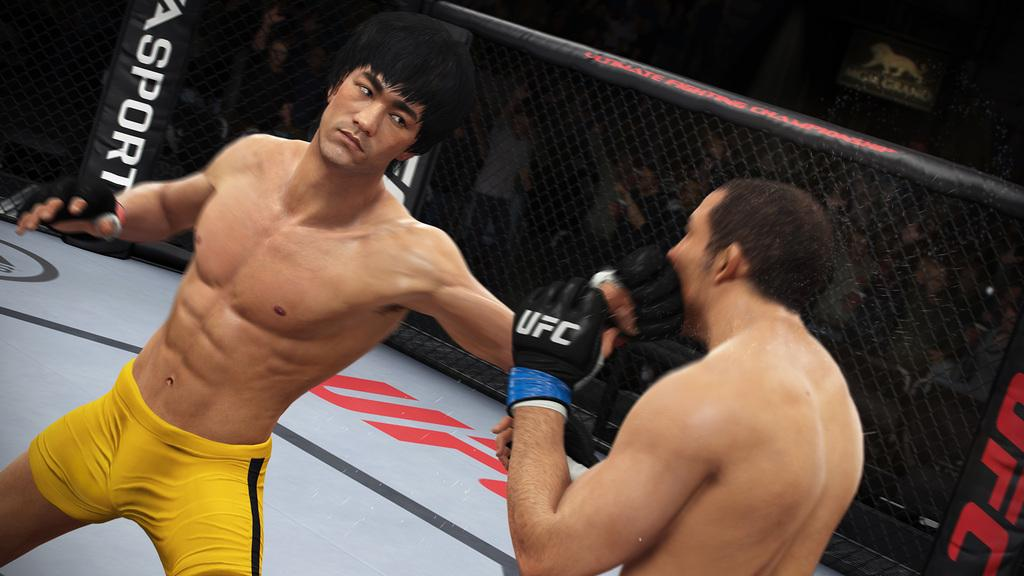Provide a one-sentence caption for the provided image. Two UFC fighters in a ring with an ad for ASport. 